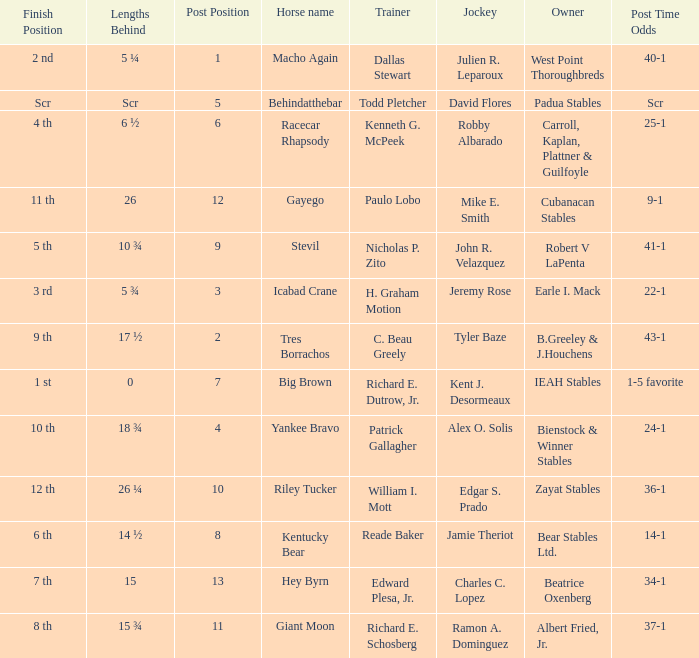What's the post position when the lengths behind is 0? 7.0. 